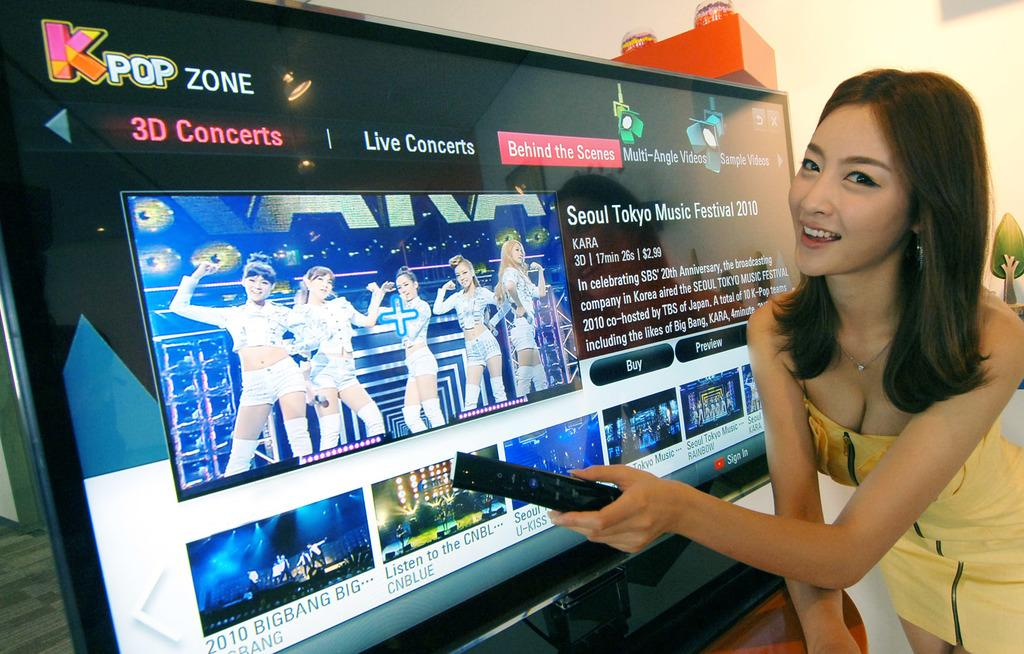Provide a one-sentence caption for the provided image. A girl is holding a remote looking at Kpop Zone. 